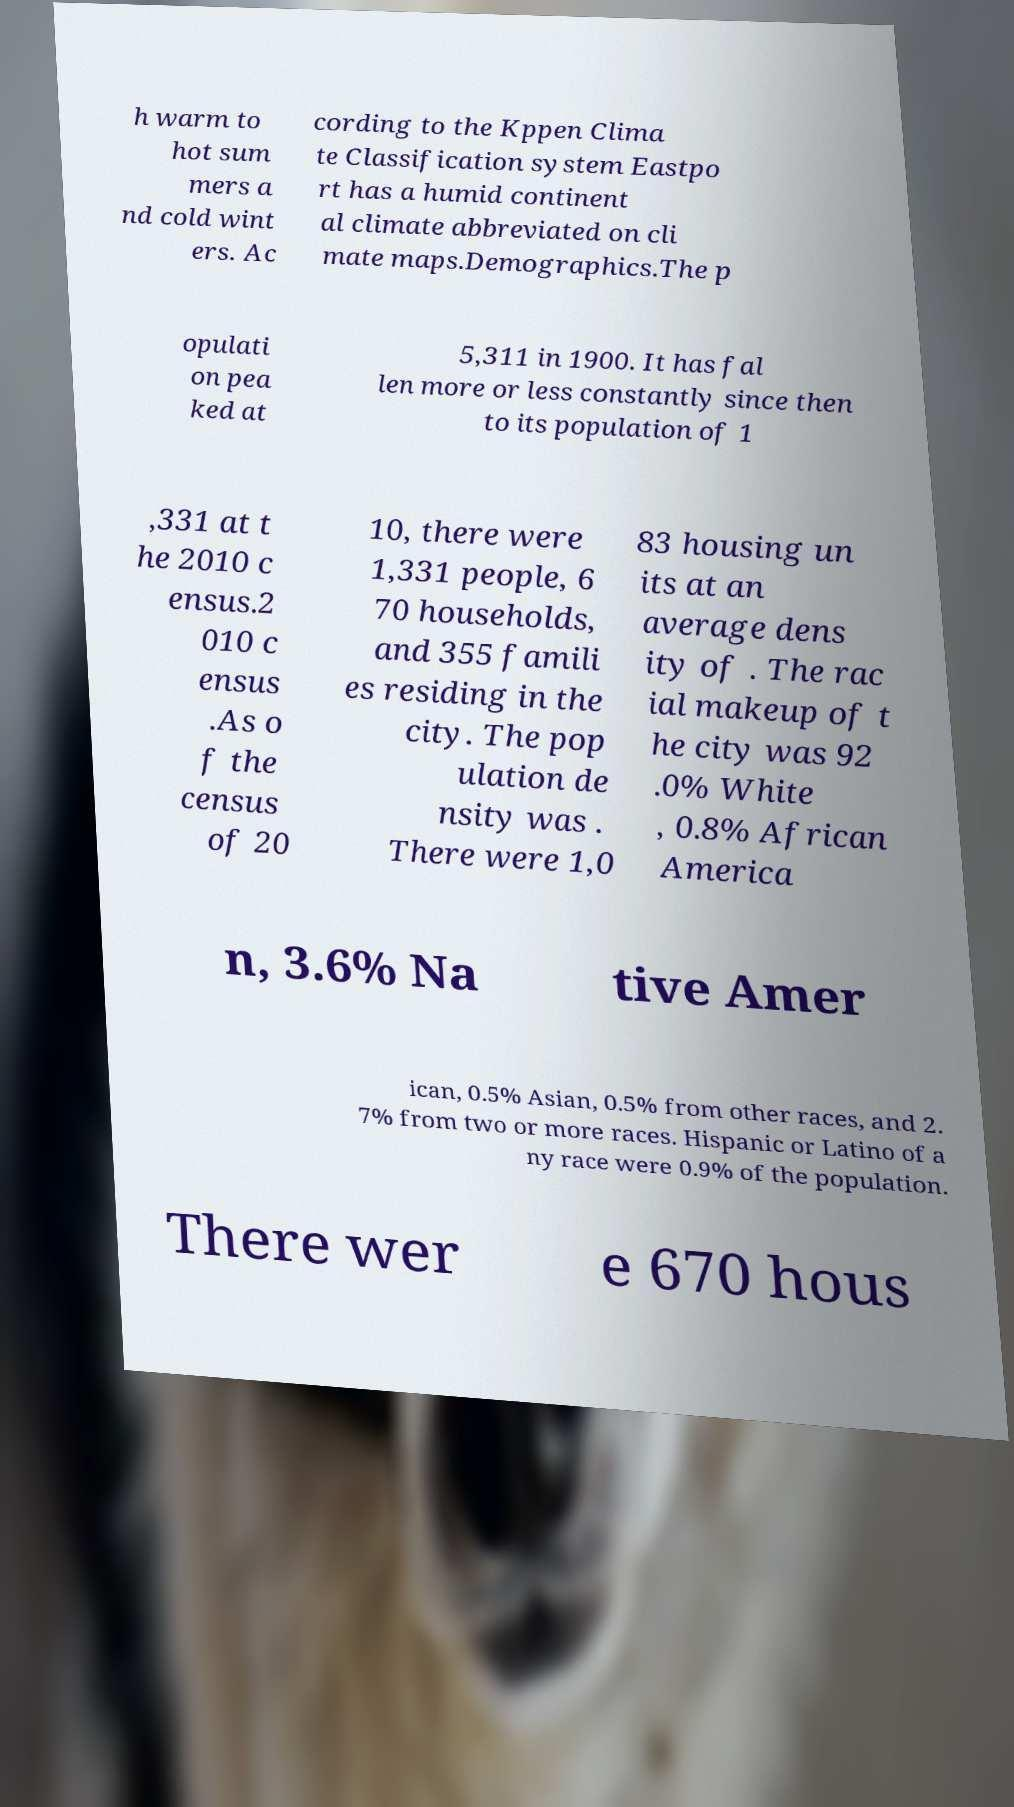What messages or text are displayed in this image? I need them in a readable, typed format. h warm to hot sum mers a nd cold wint ers. Ac cording to the Kppen Clima te Classification system Eastpo rt has a humid continent al climate abbreviated on cli mate maps.Demographics.The p opulati on pea ked at 5,311 in 1900. It has fal len more or less constantly since then to its population of 1 ,331 at t he 2010 c ensus.2 010 c ensus .As o f the census of 20 10, there were 1,331 people, 6 70 households, and 355 famili es residing in the city. The pop ulation de nsity was . There were 1,0 83 housing un its at an average dens ity of . The rac ial makeup of t he city was 92 .0% White , 0.8% African America n, 3.6% Na tive Amer ican, 0.5% Asian, 0.5% from other races, and 2. 7% from two or more races. Hispanic or Latino of a ny race were 0.9% of the population. There wer e 670 hous 